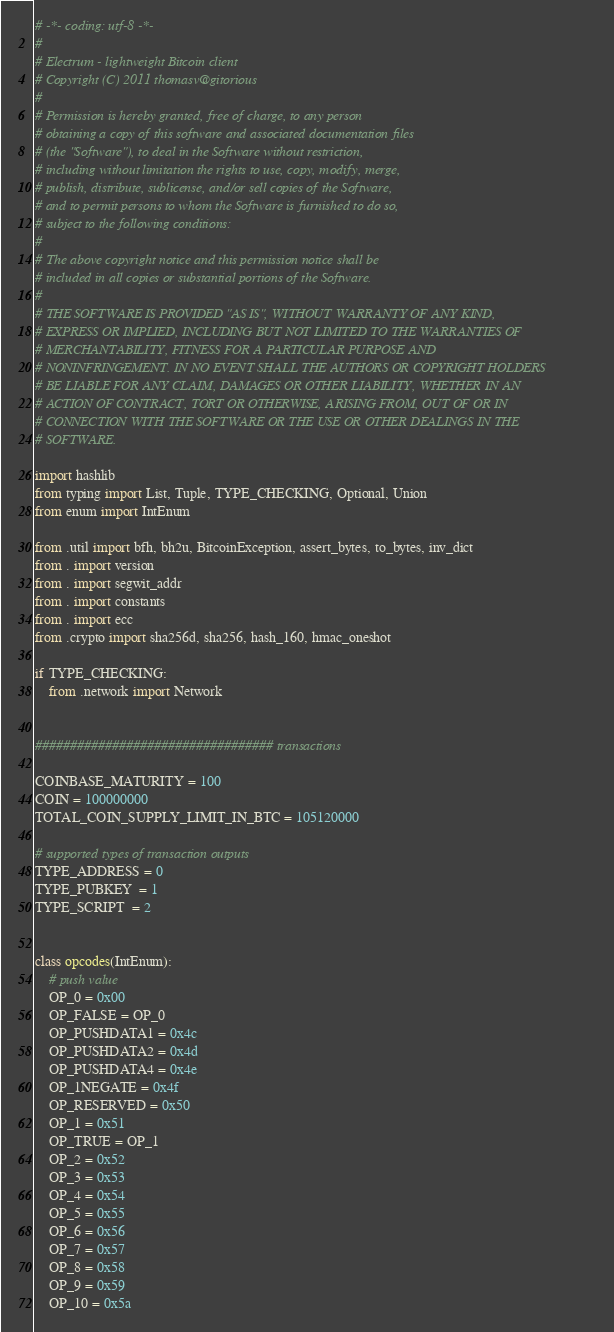Convert code to text. <code><loc_0><loc_0><loc_500><loc_500><_Python_># -*- coding: utf-8 -*-
#
# Electrum - lightweight Bitcoin client
# Copyright (C) 2011 thomasv@gitorious
#
# Permission is hereby granted, free of charge, to any person
# obtaining a copy of this software and associated documentation files
# (the "Software"), to deal in the Software without restriction,
# including without limitation the rights to use, copy, modify, merge,
# publish, distribute, sublicense, and/or sell copies of the Software,
# and to permit persons to whom the Software is furnished to do so,
# subject to the following conditions:
#
# The above copyright notice and this permission notice shall be
# included in all copies or substantial portions of the Software.
#
# THE SOFTWARE IS PROVIDED "AS IS", WITHOUT WARRANTY OF ANY KIND,
# EXPRESS OR IMPLIED, INCLUDING BUT NOT LIMITED TO THE WARRANTIES OF
# MERCHANTABILITY, FITNESS FOR A PARTICULAR PURPOSE AND
# NONINFRINGEMENT. IN NO EVENT SHALL THE AUTHORS OR COPYRIGHT HOLDERS
# BE LIABLE FOR ANY CLAIM, DAMAGES OR OTHER LIABILITY, WHETHER IN AN
# ACTION OF CONTRACT, TORT OR OTHERWISE, ARISING FROM, OUT OF OR IN
# CONNECTION WITH THE SOFTWARE OR THE USE OR OTHER DEALINGS IN THE
# SOFTWARE.

import hashlib
from typing import List, Tuple, TYPE_CHECKING, Optional, Union
from enum import IntEnum

from .util import bfh, bh2u, BitcoinException, assert_bytes, to_bytes, inv_dict
from . import version
from . import segwit_addr
from . import constants
from . import ecc
from .crypto import sha256d, sha256, hash_160, hmac_oneshot

if TYPE_CHECKING:
    from .network import Network


################################## transactions

COINBASE_MATURITY = 100
COIN = 100000000
TOTAL_COIN_SUPPLY_LIMIT_IN_BTC = 105120000

# supported types of transaction outputs
TYPE_ADDRESS = 0
TYPE_PUBKEY  = 1
TYPE_SCRIPT  = 2


class opcodes(IntEnum):
    # push value
    OP_0 = 0x00
    OP_FALSE = OP_0
    OP_PUSHDATA1 = 0x4c
    OP_PUSHDATA2 = 0x4d
    OP_PUSHDATA4 = 0x4e
    OP_1NEGATE = 0x4f
    OP_RESERVED = 0x50
    OP_1 = 0x51
    OP_TRUE = OP_1
    OP_2 = 0x52
    OP_3 = 0x53
    OP_4 = 0x54
    OP_5 = 0x55
    OP_6 = 0x56
    OP_7 = 0x57
    OP_8 = 0x58
    OP_9 = 0x59
    OP_10 = 0x5a</code> 